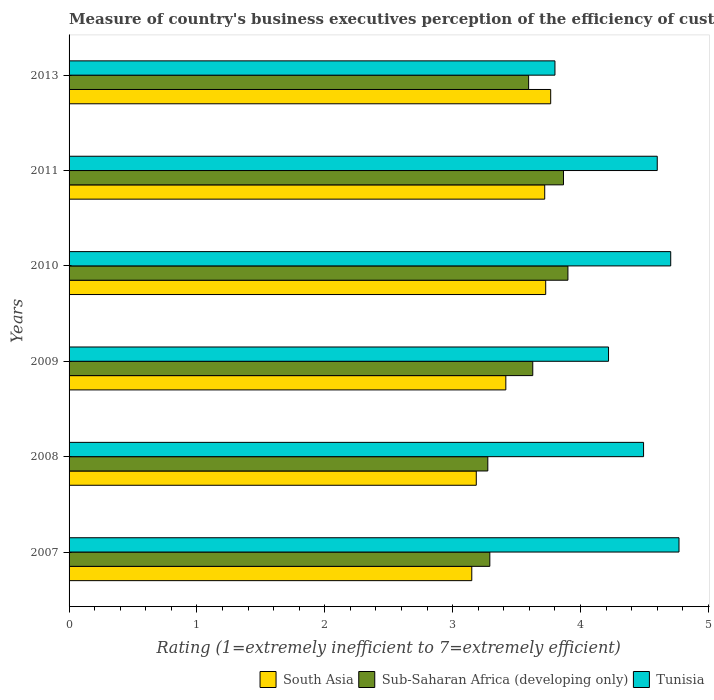How many groups of bars are there?
Offer a terse response. 6. Are the number of bars on each tick of the Y-axis equal?
Your answer should be compact. Yes. How many bars are there on the 3rd tick from the bottom?
Ensure brevity in your answer.  3. What is the label of the 5th group of bars from the top?
Ensure brevity in your answer.  2008. In how many cases, is the number of bars for a given year not equal to the number of legend labels?
Keep it short and to the point. 0. What is the rating of the efficiency of customs procedure in Sub-Saharan Africa (developing only) in 2008?
Your answer should be compact. 3.27. Across all years, what is the maximum rating of the efficiency of customs procedure in Tunisia?
Your answer should be compact. 4.77. Across all years, what is the minimum rating of the efficiency of customs procedure in Sub-Saharan Africa (developing only)?
Provide a succinct answer. 3.27. In which year was the rating of the efficiency of customs procedure in Sub-Saharan Africa (developing only) minimum?
Your answer should be very brief. 2008. What is the total rating of the efficiency of customs procedure in Tunisia in the graph?
Your answer should be compact. 26.59. What is the difference between the rating of the efficiency of customs procedure in Sub-Saharan Africa (developing only) in 2007 and that in 2010?
Your answer should be very brief. -0.61. What is the difference between the rating of the efficiency of customs procedure in South Asia in 2010 and the rating of the efficiency of customs procedure in Tunisia in 2008?
Keep it short and to the point. -0.77. What is the average rating of the efficiency of customs procedure in South Asia per year?
Offer a very short reply. 3.49. In the year 2008, what is the difference between the rating of the efficiency of customs procedure in Sub-Saharan Africa (developing only) and rating of the efficiency of customs procedure in Tunisia?
Your response must be concise. -1.22. What is the ratio of the rating of the efficiency of customs procedure in Tunisia in 2008 to that in 2009?
Make the answer very short. 1.06. Is the rating of the efficiency of customs procedure in Sub-Saharan Africa (developing only) in 2009 less than that in 2013?
Your answer should be compact. No. What is the difference between the highest and the second highest rating of the efficiency of customs procedure in South Asia?
Give a very brief answer. 0.04. What is the difference between the highest and the lowest rating of the efficiency of customs procedure in Sub-Saharan Africa (developing only)?
Make the answer very short. 0.63. In how many years, is the rating of the efficiency of customs procedure in Sub-Saharan Africa (developing only) greater than the average rating of the efficiency of customs procedure in Sub-Saharan Africa (developing only) taken over all years?
Ensure brevity in your answer.  4. What does the 2nd bar from the top in 2011 represents?
Provide a succinct answer. Sub-Saharan Africa (developing only). What does the 3rd bar from the bottom in 2011 represents?
Offer a very short reply. Tunisia. How many years are there in the graph?
Make the answer very short. 6. What is the difference between two consecutive major ticks on the X-axis?
Keep it short and to the point. 1. Does the graph contain any zero values?
Your answer should be very brief. No. Does the graph contain grids?
Your response must be concise. No. Where does the legend appear in the graph?
Keep it short and to the point. Bottom right. What is the title of the graph?
Your answer should be compact. Measure of country's business executives perception of the efficiency of customs procedures. What is the label or title of the X-axis?
Provide a short and direct response. Rating (1=extremely inefficient to 7=extremely efficient). What is the Rating (1=extremely inefficient to 7=extremely efficient) in South Asia in 2007?
Your answer should be compact. 3.15. What is the Rating (1=extremely inefficient to 7=extremely efficient) of Sub-Saharan Africa (developing only) in 2007?
Keep it short and to the point. 3.29. What is the Rating (1=extremely inefficient to 7=extremely efficient) in Tunisia in 2007?
Ensure brevity in your answer.  4.77. What is the Rating (1=extremely inefficient to 7=extremely efficient) of South Asia in 2008?
Offer a very short reply. 3.18. What is the Rating (1=extremely inefficient to 7=extremely efficient) of Sub-Saharan Africa (developing only) in 2008?
Make the answer very short. 3.27. What is the Rating (1=extremely inefficient to 7=extremely efficient) of Tunisia in 2008?
Your response must be concise. 4.49. What is the Rating (1=extremely inefficient to 7=extremely efficient) in South Asia in 2009?
Offer a very short reply. 3.42. What is the Rating (1=extremely inefficient to 7=extremely efficient) of Sub-Saharan Africa (developing only) in 2009?
Offer a very short reply. 3.63. What is the Rating (1=extremely inefficient to 7=extremely efficient) of Tunisia in 2009?
Ensure brevity in your answer.  4.22. What is the Rating (1=extremely inefficient to 7=extremely efficient) in South Asia in 2010?
Offer a terse response. 3.73. What is the Rating (1=extremely inefficient to 7=extremely efficient) in Sub-Saharan Africa (developing only) in 2010?
Your answer should be compact. 3.9. What is the Rating (1=extremely inefficient to 7=extremely efficient) in Tunisia in 2010?
Your response must be concise. 4.71. What is the Rating (1=extremely inefficient to 7=extremely efficient) of South Asia in 2011?
Give a very brief answer. 3.72. What is the Rating (1=extremely inefficient to 7=extremely efficient) in Sub-Saharan Africa (developing only) in 2011?
Provide a short and direct response. 3.87. What is the Rating (1=extremely inefficient to 7=extremely efficient) of South Asia in 2013?
Your answer should be very brief. 3.77. What is the Rating (1=extremely inefficient to 7=extremely efficient) in Sub-Saharan Africa (developing only) in 2013?
Ensure brevity in your answer.  3.59. What is the Rating (1=extremely inefficient to 7=extremely efficient) of Tunisia in 2013?
Your response must be concise. 3.8. Across all years, what is the maximum Rating (1=extremely inefficient to 7=extremely efficient) of South Asia?
Offer a terse response. 3.77. Across all years, what is the maximum Rating (1=extremely inefficient to 7=extremely efficient) in Sub-Saharan Africa (developing only)?
Offer a terse response. 3.9. Across all years, what is the maximum Rating (1=extremely inefficient to 7=extremely efficient) of Tunisia?
Your answer should be very brief. 4.77. Across all years, what is the minimum Rating (1=extremely inefficient to 7=extremely efficient) in South Asia?
Your answer should be very brief. 3.15. Across all years, what is the minimum Rating (1=extremely inefficient to 7=extremely efficient) in Sub-Saharan Africa (developing only)?
Keep it short and to the point. 3.27. Across all years, what is the minimum Rating (1=extremely inefficient to 7=extremely efficient) in Tunisia?
Your answer should be very brief. 3.8. What is the total Rating (1=extremely inefficient to 7=extremely efficient) of South Asia in the graph?
Give a very brief answer. 20.96. What is the total Rating (1=extremely inefficient to 7=extremely efficient) of Sub-Saharan Africa (developing only) in the graph?
Make the answer very short. 21.55. What is the total Rating (1=extremely inefficient to 7=extremely efficient) of Tunisia in the graph?
Ensure brevity in your answer.  26.59. What is the difference between the Rating (1=extremely inefficient to 7=extremely efficient) of South Asia in 2007 and that in 2008?
Provide a short and direct response. -0.04. What is the difference between the Rating (1=extremely inefficient to 7=extremely efficient) in Sub-Saharan Africa (developing only) in 2007 and that in 2008?
Your answer should be compact. 0.02. What is the difference between the Rating (1=extremely inefficient to 7=extremely efficient) of Tunisia in 2007 and that in 2008?
Provide a succinct answer. 0.28. What is the difference between the Rating (1=extremely inefficient to 7=extremely efficient) of South Asia in 2007 and that in 2009?
Provide a short and direct response. -0.27. What is the difference between the Rating (1=extremely inefficient to 7=extremely efficient) in Sub-Saharan Africa (developing only) in 2007 and that in 2009?
Offer a terse response. -0.34. What is the difference between the Rating (1=extremely inefficient to 7=extremely efficient) in Tunisia in 2007 and that in 2009?
Make the answer very short. 0.55. What is the difference between the Rating (1=extremely inefficient to 7=extremely efficient) in South Asia in 2007 and that in 2010?
Give a very brief answer. -0.58. What is the difference between the Rating (1=extremely inefficient to 7=extremely efficient) of Sub-Saharan Africa (developing only) in 2007 and that in 2010?
Keep it short and to the point. -0.61. What is the difference between the Rating (1=extremely inefficient to 7=extremely efficient) of Tunisia in 2007 and that in 2010?
Your answer should be very brief. 0.06. What is the difference between the Rating (1=extremely inefficient to 7=extremely efficient) of South Asia in 2007 and that in 2011?
Make the answer very short. -0.57. What is the difference between the Rating (1=extremely inefficient to 7=extremely efficient) of Sub-Saharan Africa (developing only) in 2007 and that in 2011?
Your response must be concise. -0.58. What is the difference between the Rating (1=extremely inefficient to 7=extremely efficient) of Tunisia in 2007 and that in 2011?
Ensure brevity in your answer.  0.17. What is the difference between the Rating (1=extremely inefficient to 7=extremely efficient) in South Asia in 2007 and that in 2013?
Offer a very short reply. -0.62. What is the difference between the Rating (1=extremely inefficient to 7=extremely efficient) in Sub-Saharan Africa (developing only) in 2007 and that in 2013?
Provide a short and direct response. -0.3. What is the difference between the Rating (1=extremely inefficient to 7=extremely efficient) in Tunisia in 2007 and that in 2013?
Your response must be concise. 0.97. What is the difference between the Rating (1=extremely inefficient to 7=extremely efficient) of South Asia in 2008 and that in 2009?
Offer a terse response. -0.23. What is the difference between the Rating (1=extremely inefficient to 7=extremely efficient) of Sub-Saharan Africa (developing only) in 2008 and that in 2009?
Make the answer very short. -0.35. What is the difference between the Rating (1=extremely inefficient to 7=extremely efficient) in Tunisia in 2008 and that in 2009?
Keep it short and to the point. 0.27. What is the difference between the Rating (1=extremely inefficient to 7=extremely efficient) in South Asia in 2008 and that in 2010?
Keep it short and to the point. -0.54. What is the difference between the Rating (1=extremely inefficient to 7=extremely efficient) of Sub-Saharan Africa (developing only) in 2008 and that in 2010?
Your response must be concise. -0.63. What is the difference between the Rating (1=extremely inefficient to 7=extremely efficient) in Tunisia in 2008 and that in 2010?
Offer a terse response. -0.21. What is the difference between the Rating (1=extremely inefficient to 7=extremely efficient) in South Asia in 2008 and that in 2011?
Make the answer very short. -0.54. What is the difference between the Rating (1=extremely inefficient to 7=extremely efficient) in Sub-Saharan Africa (developing only) in 2008 and that in 2011?
Make the answer very short. -0.59. What is the difference between the Rating (1=extremely inefficient to 7=extremely efficient) of Tunisia in 2008 and that in 2011?
Your answer should be compact. -0.11. What is the difference between the Rating (1=extremely inefficient to 7=extremely efficient) in South Asia in 2008 and that in 2013?
Give a very brief answer. -0.58. What is the difference between the Rating (1=extremely inefficient to 7=extremely efficient) of Sub-Saharan Africa (developing only) in 2008 and that in 2013?
Your response must be concise. -0.32. What is the difference between the Rating (1=extremely inefficient to 7=extremely efficient) in Tunisia in 2008 and that in 2013?
Offer a terse response. 0.69. What is the difference between the Rating (1=extremely inefficient to 7=extremely efficient) in South Asia in 2009 and that in 2010?
Offer a terse response. -0.31. What is the difference between the Rating (1=extremely inefficient to 7=extremely efficient) of Sub-Saharan Africa (developing only) in 2009 and that in 2010?
Offer a terse response. -0.27. What is the difference between the Rating (1=extremely inefficient to 7=extremely efficient) in Tunisia in 2009 and that in 2010?
Your answer should be compact. -0.49. What is the difference between the Rating (1=extremely inefficient to 7=extremely efficient) of South Asia in 2009 and that in 2011?
Ensure brevity in your answer.  -0.3. What is the difference between the Rating (1=extremely inefficient to 7=extremely efficient) of Sub-Saharan Africa (developing only) in 2009 and that in 2011?
Ensure brevity in your answer.  -0.24. What is the difference between the Rating (1=extremely inefficient to 7=extremely efficient) in Tunisia in 2009 and that in 2011?
Provide a short and direct response. -0.38. What is the difference between the Rating (1=extremely inefficient to 7=extremely efficient) in South Asia in 2009 and that in 2013?
Provide a succinct answer. -0.35. What is the difference between the Rating (1=extremely inefficient to 7=extremely efficient) in Sub-Saharan Africa (developing only) in 2009 and that in 2013?
Give a very brief answer. 0.03. What is the difference between the Rating (1=extremely inefficient to 7=extremely efficient) in Tunisia in 2009 and that in 2013?
Keep it short and to the point. 0.42. What is the difference between the Rating (1=extremely inefficient to 7=extremely efficient) of South Asia in 2010 and that in 2011?
Your response must be concise. 0.01. What is the difference between the Rating (1=extremely inefficient to 7=extremely efficient) in Sub-Saharan Africa (developing only) in 2010 and that in 2011?
Provide a short and direct response. 0.03. What is the difference between the Rating (1=extremely inefficient to 7=extremely efficient) of Tunisia in 2010 and that in 2011?
Give a very brief answer. 0.11. What is the difference between the Rating (1=extremely inefficient to 7=extremely efficient) in South Asia in 2010 and that in 2013?
Keep it short and to the point. -0.04. What is the difference between the Rating (1=extremely inefficient to 7=extremely efficient) of Sub-Saharan Africa (developing only) in 2010 and that in 2013?
Give a very brief answer. 0.31. What is the difference between the Rating (1=extremely inefficient to 7=extremely efficient) in Tunisia in 2010 and that in 2013?
Ensure brevity in your answer.  0.91. What is the difference between the Rating (1=extremely inefficient to 7=extremely efficient) of South Asia in 2011 and that in 2013?
Make the answer very short. -0.05. What is the difference between the Rating (1=extremely inefficient to 7=extremely efficient) in Sub-Saharan Africa (developing only) in 2011 and that in 2013?
Ensure brevity in your answer.  0.27. What is the difference between the Rating (1=extremely inefficient to 7=extremely efficient) in South Asia in 2007 and the Rating (1=extremely inefficient to 7=extremely efficient) in Sub-Saharan Africa (developing only) in 2008?
Your answer should be compact. -0.13. What is the difference between the Rating (1=extremely inefficient to 7=extremely efficient) of South Asia in 2007 and the Rating (1=extremely inefficient to 7=extremely efficient) of Tunisia in 2008?
Offer a very short reply. -1.34. What is the difference between the Rating (1=extremely inefficient to 7=extremely efficient) in Sub-Saharan Africa (developing only) in 2007 and the Rating (1=extremely inefficient to 7=extremely efficient) in Tunisia in 2008?
Give a very brief answer. -1.2. What is the difference between the Rating (1=extremely inefficient to 7=extremely efficient) of South Asia in 2007 and the Rating (1=extremely inefficient to 7=extremely efficient) of Sub-Saharan Africa (developing only) in 2009?
Provide a succinct answer. -0.48. What is the difference between the Rating (1=extremely inefficient to 7=extremely efficient) of South Asia in 2007 and the Rating (1=extremely inefficient to 7=extremely efficient) of Tunisia in 2009?
Provide a short and direct response. -1.07. What is the difference between the Rating (1=extremely inefficient to 7=extremely efficient) of Sub-Saharan Africa (developing only) in 2007 and the Rating (1=extremely inefficient to 7=extremely efficient) of Tunisia in 2009?
Keep it short and to the point. -0.93. What is the difference between the Rating (1=extremely inefficient to 7=extremely efficient) in South Asia in 2007 and the Rating (1=extremely inefficient to 7=extremely efficient) in Sub-Saharan Africa (developing only) in 2010?
Ensure brevity in your answer.  -0.75. What is the difference between the Rating (1=extremely inefficient to 7=extremely efficient) in South Asia in 2007 and the Rating (1=extremely inefficient to 7=extremely efficient) in Tunisia in 2010?
Keep it short and to the point. -1.56. What is the difference between the Rating (1=extremely inefficient to 7=extremely efficient) of Sub-Saharan Africa (developing only) in 2007 and the Rating (1=extremely inefficient to 7=extremely efficient) of Tunisia in 2010?
Make the answer very short. -1.41. What is the difference between the Rating (1=extremely inefficient to 7=extremely efficient) of South Asia in 2007 and the Rating (1=extremely inefficient to 7=extremely efficient) of Sub-Saharan Africa (developing only) in 2011?
Offer a terse response. -0.72. What is the difference between the Rating (1=extremely inefficient to 7=extremely efficient) of South Asia in 2007 and the Rating (1=extremely inefficient to 7=extremely efficient) of Tunisia in 2011?
Provide a short and direct response. -1.45. What is the difference between the Rating (1=extremely inefficient to 7=extremely efficient) in Sub-Saharan Africa (developing only) in 2007 and the Rating (1=extremely inefficient to 7=extremely efficient) in Tunisia in 2011?
Your answer should be compact. -1.31. What is the difference between the Rating (1=extremely inefficient to 7=extremely efficient) in South Asia in 2007 and the Rating (1=extremely inefficient to 7=extremely efficient) in Sub-Saharan Africa (developing only) in 2013?
Your answer should be very brief. -0.44. What is the difference between the Rating (1=extremely inefficient to 7=extremely efficient) of South Asia in 2007 and the Rating (1=extremely inefficient to 7=extremely efficient) of Tunisia in 2013?
Your response must be concise. -0.65. What is the difference between the Rating (1=extremely inefficient to 7=extremely efficient) in Sub-Saharan Africa (developing only) in 2007 and the Rating (1=extremely inefficient to 7=extremely efficient) in Tunisia in 2013?
Ensure brevity in your answer.  -0.51. What is the difference between the Rating (1=extremely inefficient to 7=extremely efficient) in South Asia in 2008 and the Rating (1=extremely inefficient to 7=extremely efficient) in Sub-Saharan Africa (developing only) in 2009?
Provide a succinct answer. -0.44. What is the difference between the Rating (1=extremely inefficient to 7=extremely efficient) in South Asia in 2008 and the Rating (1=extremely inefficient to 7=extremely efficient) in Tunisia in 2009?
Provide a succinct answer. -1.03. What is the difference between the Rating (1=extremely inefficient to 7=extremely efficient) of Sub-Saharan Africa (developing only) in 2008 and the Rating (1=extremely inefficient to 7=extremely efficient) of Tunisia in 2009?
Make the answer very short. -0.94. What is the difference between the Rating (1=extremely inefficient to 7=extremely efficient) of South Asia in 2008 and the Rating (1=extremely inefficient to 7=extremely efficient) of Sub-Saharan Africa (developing only) in 2010?
Provide a succinct answer. -0.72. What is the difference between the Rating (1=extremely inefficient to 7=extremely efficient) in South Asia in 2008 and the Rating (1=extremely inefficient to 7=extremely efficient) in Tunisia in 2010?
Offer a very short reply. -1.52. What is the difference between the Rating (1=extremely inefficient to 7=extremely efficient) in Sub-Saharan Africa (developing only) in 2008 and the Rating (1=extremely inefficient to 7=extremely efficient) in Tunisia in 2010?
Your answer should be very brief. -1.43. What is the difference between the Rating (1=extremely inefficient to 7=extremely efficient) in South Asia in 2008 and the Rating (1=extremely inefficient to 7=extremely efficient) in Sub-Saharan Africa (developing only) in 2011?
Make the answer very short. -0.68. What is the difference between the Rating (1=extremely inefficient to 7=extremely efficient) of South Asia in 2008 and the Rating (1=extremely inefficient to 7=extremely efficient) of Tunisia in 2011?
Provide a succinct answer. -1.42. What is the difference between the Rating (1=extremely inefficient to 7=extremely efficient) in Sub-Saharan Africa (developing only) in 2008 and the Rating (1=extremely inefficient to 7=extremely efficient) in Tunisia in 2011?
Offer a terse response. -1.33. What is the difference between the Rating (1=extremely inefficient to 7=extremely efficient) in South Asia in 2008 and the Rating (1=extremely inefficient to 7=extremely efficient) in Sub-Saharan Africa (developing only) in 2013?
Provide a succinct answer. -0.41. What is the difference between the Rating (1=extremely inefficient to 7=extremely efficient) in South Asia in 2008 and the Rating (1=extremely inefficient to 7=extremely efficient) in Tunisia in 2013?
Make the answer very short. -0.62. What is the difference between the Rating (1=extremely inefficient to 7=extremely efficient) in Sub-Saharan Africa (developing only) in 2008 and the Rating (1=extremely inefficient to 7=extremely efficient) in Tunisia in 2013?
Your response must be concise. -0.53. What is the difference between the Rating (1=extremely inefficient to 7=extremely efficient) in South Asia in 2009 and the Rating (1=extremely inefficient to 7=extremely efficient) in Sub-Saharan Africa (developing only) in 2010?
Provide a short and direct response. -0.49. What is the difference between the Rating (1=extremely inefficient to 7=extremely efficient) in South Asia in 2009 and the Rating (1=extremely inefficient to 7=extremely efficient) in Tunisia in 2010?
Make the answer very short. -1.29. What is the difference between the Rating (1=extremely inefficient to 7=extremely efficient) of Sub-Saharan Africa (developing only) in 2009 and the Rating (1=extremely inefficient to 7=extremely efficient) of Tunisia in 2010?
Provide a short and direct response. -1.08. What is the difference between the Rating (1=extremely inefficient to 7=extremely efficient) of South Asia in 2009 and the Rating (1=extremely inefficient to 7=extremely efficient) of Sub-Saharan Africa (developing only) in 2011?
Offer a very short reply. -0.45. What is the difference between the Rating (1=extremely inefficient to 7=extremely efficient) of South Asia in 2009 and the Rating (1=extremely inefficient to 7=extremely efficient) of Tunisia in 2011?
Your response must be concise. -1.18. What is the difference between the Rating (1=extremely inefficient to 7=extremely efficient) in Sub-Saharan Africa (developing only) in 2009 and the Rating (1=extremely inefficient to 7=extremely efficient) in Tunisia in 2011?
Offer a very short reply. -0.97. What is the difference between the Rating (1=extremely inefficient to 7=extremely efficient) in South Asia in 2009 and the Rating (1=extremely inefficient to 7=extremely efficient) in Sub-Saharan Africa (developing only) in 2013?
Keep it short and to the point. -0.18. What is the difference between the Rating (1=extremely inefficient to 7=extremely efficient) of South Asia in 2009 and the Rating (1=extremely inefficient to 7=extremely efficient) of Tunisia in 2013?
Your answer should be very brief. -0.38. What is the difference between the Rating (1=extremely inefficient to 7=extremely efficient) of Sub-Saharan Africa (developing only) in 2009 and the Rating (1=extremely inefficient to 7=extremely efficient) of Tunisia in 2013?
Offer a terse response. -0.17. What is the difference between the Rating (1=extremely inefficient to 7=extremely efficient) in South Asia in 2010 and the Rating (1=extremely inefficient to 7=extremely efficient) in Sub-Saharan Africa (developing only) in 2011?
Offer a very short reply. -0.14. What is the difference between the Rating (1=extremely inefficient to 7=extremely efficient) of South Asia in 2010 and the Rating (1=extremely inefficient to 7=extremely efficient) of Tunisia in 2011?
Keep it short and to the point. -0.87. What is the difference between the Rating (1=extremely inefficient to 7=extremely efficient) in Sub-Saharan Africa (developing only) in 2010 and the Rating (1=extremely inefficient to 7=extremely efficient) in Tunisia in 2011?
Your answer should be compact. -0.7. What is the difference between the Rating (1=extremely inefficient to 7=extremely efficient) of South Asia in 2010 and the Rating (1=extremely inefficient to 7=extremely efficient) of Sub-Saharan Africa (developing only) in 2013?
Your answer should be very brief. 0.13. What is the difference between the Rating (1=extremely inefficient to 7=extremely efficient) of South Asia in 2010 and the Rating (1=extremely inefficient to 7=extremely efficient) of Tunisia in 2013?
Offer a very short reply. -0.07. What is the difference between the Rating (1=extremely inefficient to 7=extremely efficient) of Sub-Saharan Africa (developing only) in 2010 and the Rating (1=extremely inefficient to 7=extremely efficient) of Tunisia in 2013?
Provide a succinct answer. 0.1. What is the difference between the Rating (1=extremely inefficient to 7=extremely efficient) of South Asia in 2011 and the Rating (1=extremely inefficient to 7=extremely efficient) of Sub-Saharan Africa (developing only) in 2013?
Keep it short and to the point. 0.13. What is the difference between the Rating (1=extremely inefficient to 7=extremely efficient) of South Asia in 2011 and the Rating (1=extremely inefficient to 7=extremely efficient) of Tunisia in 2013?
Offer a very short reply. -0.08. What is the difference between the Rating (1=extremely inefficient to 7=extremely efficient) of Sub-Saharan Africa (developing only) in 2011 and the Rating (1=extremely inefficient to 7=extremely efficient) of Tunisia in 2013?
Offer a terse response. 0.07. What is the average Rating (1=extremely inefficient to 7=extremely efficient) of South Asia per year?
Your response must be concise. 3.49. What is the average Rating (1=extremely inefficient to 7=extremely efficient) of Sub-Saharan Africa (developing only) per year?
Offer a terse response. 3.59. What is the average Rating (1=extremely inefficient to 7=extremely efficient) in Tunisia per year?
Provide a short and direct response. 4.43. In the year 2007, what is the difference between the Rating (1=extremely inefficient to 7=extremely efficient) of South Asia and Rating (1=extremely inefficient to 7=extremely efficient) of Sub-Saharan Africa (developing only)?
Provide a short and direct response. -0.14. In the year 2007, what is the difference between the Rating (1=extremely inefficient to 7=extremely efficient) in South Asia and Rating (1=extremely inefficient to 7=extremely efficient) in Tunisia?
Offer a very short reply. -1.62. In the year 2007, what is the difference between the Rating (1=extremely inefficient to 7=extremely efficient) of Sub-Saharan Africa (developing only) and Rating (1=extremely inefficient to 7=extremely efficient) of Tunisia?
Give a very brief answer. -1.48. In the year 2008, what is the difference between the Rating (1=extremely inefficient to 7=extremely efficient) in South Asia and Rating (1=extremely inefficient to 7=extremely efficient) in Sub-Saharan Africa (developing only)?
Your answer should be compact. -0.09. In the year 2008, what is the difference between the Rating (1=extremely inefficient to 7=extremely efficient) of South Asia and Rating (1=extremely inefficient to 7=extremely efficient) of Tunisia?
Give a very brief answer. -1.31. In the year 2008, what is the difference between the Rating (1=extremely inefficient to 7=extremely efficient) in Sub-Saharan Africa (developing only) and Rating (1=extremely inefficient to 7=extremely efficient) in Tunisia?
Make the answer very short. -1.22. In the year 2009, what is the difference between the Rating (1=extremely inefficient to 7=extremely efficient) in South Asia and Rating (1=extremely inefficient to 7=extremely efficient) in Sub-Saharan Africa (developing only)?
Give a very brief answer. -0.21. In the year 2009, what is the difference between the Rating (1=extremely inefficient to 7=extremely efficient) of South Asia and Rating (1=extremely inefficient to 7=extremely efficient) of Tunisia?
Provide a short and direct response. -0.8. In the year 2009, what is the difference between the Rating (1=extremely inefficient to 7=extremely efficient) of Sub-Saharan Africa (developing only) and Rating (1=extremely inefficient to 7=extremely efficient) of Tunisia?
Offer a very short reply. -0.59. In the year 2010, what is the difference between the Rating (1=extremely inefficient to 7=extremely efficient) in South Asia and Rating (1=extremely inefficient to 7=extremely efficient) in Sub-Saharan Africa (developing only)?
Offer a very short reply. -0.17. In the year 2010, what is the difference between the Rating (1=extremely inefficient to 7=extremely efficient) of South Asia and Rating (1=extremely inefficient to 7=extremely efficient) of Tunisia?
Your answer should be compact. -0.98. In the year 2010, what is the difference between the Rating (1=extremely inefficient to 7=extremely efficient) in Sub-Saharan Africa (developing only) and Rating (1=extremely inefficient to 7=extremely efficient) in Tunisia?
Keep it short and to the point. -0.8. In the year 2011, what is the difference between the Rating (1=extremely inefficient to 7=extremely efficient) of South Asia and Rating (1=extremely inefficient to 7=extremely efficient) of Sub-Saharan Africa (developing only)?
Keep it short and to the point. -0.15. In the year 2011, what is the difference between the Rating (1=extremely inefficient to 7=extremely efficient) in South Asia and Rating (1=extremely inefficient to 7=extremely efficient) in Tunisia?
Provide a succinct answer. -0.88. In the year 2011, what is the difference between the Rating (1=extremely inefficient to 7=extremely efficient) in Sub-Saharan Africa (developing only) and Rating (1=extremely inefficient to 7=extremely efficient) in Tunisia?
Provide a short and direct response. -0.73. In the year 2013, what is the difference between the Rating (1=extremely inefficient to 7=extremely efficient) of South Asia and Rating (1=extremely inefficient to 7=extremely efficient) of Sub-Saharan Africa (developing only)?
Provide a short and direct response. 0.17. In the year 2013, what is the difference between the Rating (1=extremely inefficient to 7=extremely efficient) in South Asia and Rating (1=extremely inefficient to 7=extremely efficient) in Tunisia?
Provide a short and direct response. -0.03. In the year 2013, what is the difference between the Rating (1=extremely inefficient to 7=extremely efficient) in Sub-Saharan Africa (developing only) and Rating (1=extremely inefficient to 7=extremely efficient) in Tunisia?
Your answer should be very brief. -0.21. What is the ratio of the Rating (1=extremely inefficient to 7=extremely efficient) in Tunisia in 2007 to that in 2008?
Give a very brief answer. 1.06. What is the ratio of the Rating (1=extremely inefficient to 7=extremely efficient) of South Asia in 2007 to that in 2009?
Offer a very short reply. 0.92. What is the ratio of the Rating (1=extremely inefficient to 7=extremely efficient) of Sub-Saharan Africa (developing only) in 2007 to that in 2009?
Offer a very short reply. 0.91. What is the ratio of the Rating (1=extremely inefficient to 7=extremely efficient) of Tunisia in 2007 to that in 2009?
Your answer should be compact. 1.13. What is the ratio of the Rating (1=extremely inefficient to 7=extremely efficient) of South Asia in 2007 to that in 2010?
Offer a terse response. 0.84. What is the ratio of the Rating (1=extremely inefficient to 7=extremely efficient) of Sub-Saharan Africa (developing only) in 2007 to that in 2010?
Keep it short and to the point. 0.84. What is the ratio of the Rating (1=extremely inefficient to 7=extremely efficient) of Tunisia in 2007 to that in 2010?
Your response must be concise. 1.01. What is the ratio of the Rating (1=extremely inefficient to 7=extremely efficient) in South Asia in 2007 to that in 2011?
Keep it short and to the point. 0.85. What is the ratio of the Rating (1=extremely inefficient to 7=extremely efficient) of Sub-Saharan Africa (developing only) in 2007 to that in 2011?
Make the answer very short. 0.85. What is the ratio of the Rating (1=extremely inefficient to 7=extremely efficient) in Tunisia in 2007 to that in 2011?
Provide a succinct answer. 1.04. What is the ratio of the Rating (1=extremely inefficient to 7=extremely efficient) of South Asia in 2007 to that in 2013?
Make the answer very short. 0.84. What is the ratio of the Rating (1=extremely inefficient to 7=extremely efficient) in Sub-Saharan Africa (developing only) in 2007 to that in 2013?
Offer a very short reply. 0.92. What is the ratio of the Rating (1=extremely inefficient to 7=extremely efficient) of Tunisia in 2007 to that in 2013?
Keep it short and to the point. 1.26. What is the ratio of the Rating (1=extremely inefficient to 7=extremely efficient) in South Asia in 2008 to that in 2009?
Keep it short and to the point. 0.93. What is the ratio of the Rating (1=extremely inefficient to 7=extremely efficient) in Sub-Saharan Africa (developing only) in 2008 to that in 2009?
Give a very brief answer. 0.9. What is the ratio of the Rating (1=extremely inefficient to 7=extremely efficient) of Tunisia in 2008 to that in 2009?
Make the answer very short. 1.06. What is the ratio of the Rating (1=extremely inefficient to 7=extremely efficient) of South Asia in 2008 to that in 2010?
Make the answer very short. 0.85. What is the ratio of the Rating (1=extremely inefficient to 7=extremely efficient) of Sub-Saharan Africa (developing only) in 2008 to that in 2010?
Offer a terse response. 0.84. What is the ratio of the Rating (1=extremely inefficient to 7=extremely efficient) of Tunisia in 2008 to that in 2010?
Ensure brevity in your answer.  0.95. What is the ratio of the Rating (1=extremely inefficient to 7=extremely efficient) of South Asia in 2008 to that in 2011?
Your response must be concise. 0.86. What is the ratio of the Rating (1=extremely inefficient to 7=extremely efficient) in Sub-Saharan Africa (developing only) in 2008 to that in 2011?
Offer a terse response. 0.85. What is the ratio of the Rating (1=extremely inefficient to 7=extremely efficient) in Tunisia in 2008 to that in 2011?
Give a very brief answer. 0.98. What is the ratio of the Rating (1=extremely inefficient to 7=extremely efficient) of South Asia in 2008 to that in 2013?
Your answer should be very brief. 0.85. What is the ratio of the Rating (1=extremely inefficient to 7=extremely efficient) of Sub-Saharan Africa (developing only) in 2008 to that in 2013?
Your answer should be very brief. 0.91. What is the ratio of the Rating (1=extremely inefficient to 7=extremely efficient) of Tunisia in 2008 to that in 2013?
Ensure brevity in your answer.  1.18. What is the ratio of the Rating (1=extremely inefficient to 7=extremely efficient) in South Asia in 2009 to that in 2010?
Your answer should be very brief. 0.92. What is the ratio of the Rating (1=extremely inefficient to 7=extremely efficient) in Sub-Saharan Africa (developing only) in 2009 to that in 2010?
Your response must be concise. 0.93. What is the ratio of the Rating (1=extremely inefficient to 7=extremely efficient) of Tunisia in 2009 to that in 2010?
Your answer should be compact. 0.9. What is the ratio of the Rating (1=extremely inefficient to 7=extremely efficient) in South Asia in 2009 to that in 2011?
Keep it short and to the point. 0.92. What is the ratio of the Rating (1=extremely inefficient to 7=extremely efficient) in Sub-Saharan Africa (developing only) in 2009 to that in 2011?
Provide a short and direct response. 0.94. What is the ratio of the Rating (1=extremely inefficient to 7=extremely efficient) in Tunisia in 2009 to that in 2011?
Your answer should be compact. 0.92. What is the ratio of the Rating (1=extremely inefficient to 7=extremely efficient) in South Asia in 2009 to that in 2013?
Your response must be concise. 0.91. What is the ratio of the Rating (1=extremely inefficient to 7=extremely efficient) in Tunisia in 2009 to that in 2013?
Keep it short and to the point. 1.11. What is the ratio of the Rating (1=extremely inefficient to 7=extremely efficient) in Sub-Saharan Africa (developing only) in 2010 to that in 2011?
Provide a succinct answer. 1.01. What is the ratio of the Rating (1=extremely inefficient to 7=extremely efficient) of Tunisia in 2010 to that in 2011?
Offer a very short reply. 1.02. What is the ratio of the Rating (1=extremely inefficient to 7=extremely efficient) in Sub-Saharan Africa (developing only) in 2010 to that in 2013?
Make the answer very short. 1.09. What is the ratio of the Rating (1=extremely inefficient to 7=extremely efficient) in Tunisia in 2010 to that in 2013?
Give a very brief answer. 1.24. What is the ratio of the Rating (1=extremely inefficient to 7=extremely efficient) in South Asia in 2011 to that in 2013?
Keep it short and to the point. 0.99. What is the ratio of the Rating (1=extremely inefficient to 7=extremely efficient) of Sub-Saharan Africa (developing only) in 2011 to that in 2013?
Your answer should be compact. 1.08. What is the ratio of the Rating (1=extremely inefficient to 7=extremely efficient) of Tunisia in 2011 to that in 2013?
Give a very brief answer. 1.21. What is the difference between the highest and the second highest Rating (1=extremely inefficient to 7=extremely efficient) of South Asia?
Provide a succinct answer. 0.04. What is the difference between the highest and the second highest Rating (1=extremely inefficient to 7=extremely efficient) in Sub-Saharan Africa (developing only)?
Give a very brief answer. 0.03. What is the difference between the highest and the second highest Rating (1=extremely inefficient to 7=extremely efficient) in Tunisia?
Your answer should be compact. 0.06. What is the difference between the highest and the lowest Rating (1=extremely inefficient to 7=extremely efficient) of South Asia?
Provide a succinct answer. 0.62. What is the difference between the highest and the lowest Rating (1=extremely inefficient to 7=extremely efficient) of Sub-Saharan Africa (developing only)?
Keep it short and to the point. 0.63. What is the difference between the highest and the lowest Rating (1=extremely inefficient to 7=extremely efficient) of Tunisia?
Offer a very short reply. 0.97. 